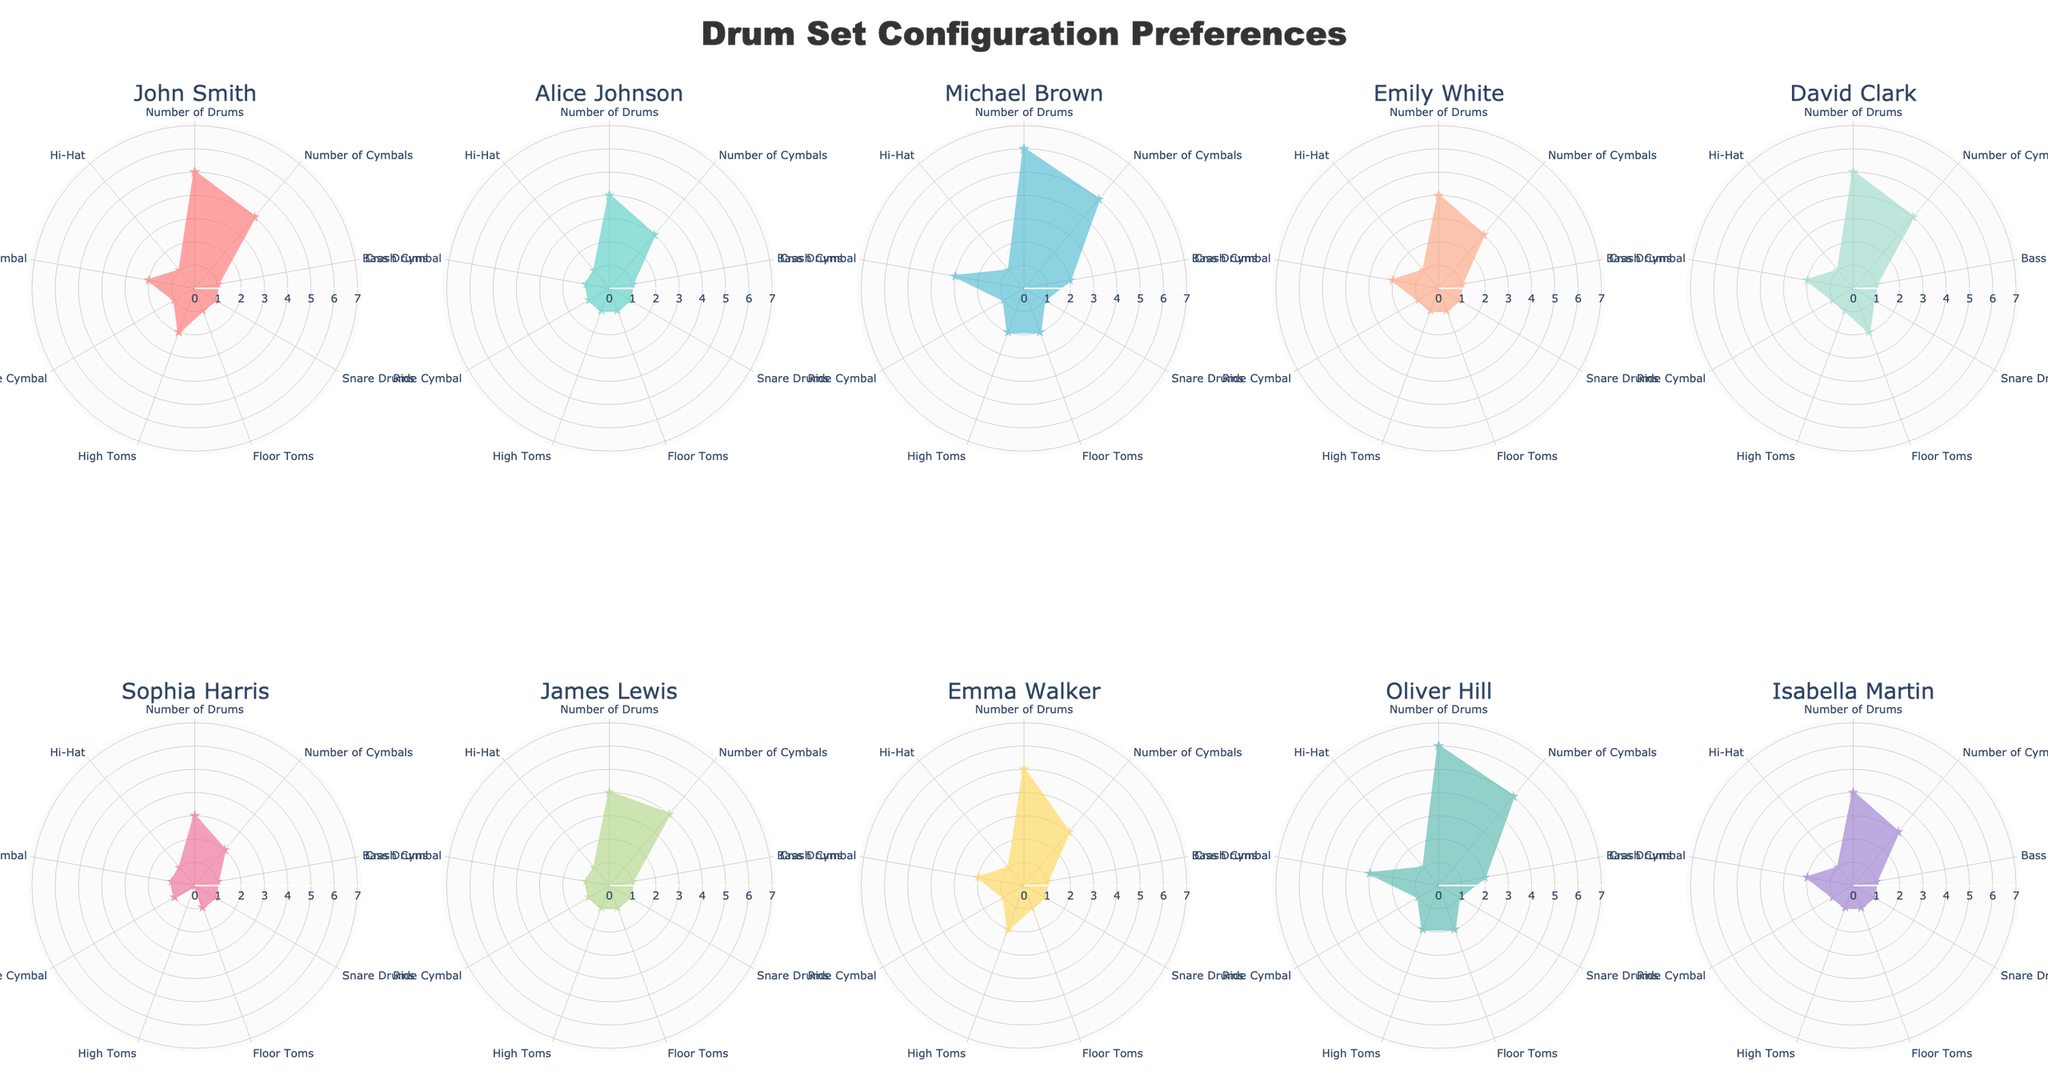Which drummer has the most Bass Drums? Observing the radar charts, Michael Brown and Oliver Hill both have the most Bass Drums, with a count of 2.
Answer: Michael Brown and Oliver Hill Which drummer uses the fewest Cymbals? By looking at each radar chart, Sophia Harris has the fewest Cymbals, using only 2.
Answer: Sophia Harris What is the total number of Bass Drums used by all drummers? Summing the number of Bass Drums from each drummer (1 + 1 + 2 + 1 + 1 + 1 + 1 + 1 + 2 + 1) results in a total of 12 Bass Drums.
Answer: 12 Compare the number of Floor Toms between David Clark and Alice Johnson. Who uses more? Observing their radar charts, David Clark uses 2 Floor Toms while Alice Johnson uses 1. David Clark uses more Floor Toms.
Answer: David Clark Which drummer has the largest drum set (in terms of the number of Drums)? By observing the radar charts, Michael Brown and Oliver Hill have the largest sets with 6 Drums each.
Answer: Michael Brown and Oliver Hill What is the average number of Cymbals used by all drummers? Summing the number of Cymbals from all drummers (4 + 3 + 5 + 3 + 4 + 2 + 4 + 3 + 5 + 3) results in 36, and there are 10 drummers, so the average is 36 / 10 = 3.6.
Answer: 3.6 Compare John Smith’s and Emma Walker’s configurations. Do they use the same number of High Toms? John Smith has 2 High Toms and Emma Walker also has 2 High Toms according to their radar charts.
Answer: Yes Identify the drummer with the simplest (fewest components) configuration. Sophia Harris has the fewest components, with smaller counts across various types of drums and cymbals.
Answer: Sophia Harris How many drummers use more than 1 Ride Cymbal? Observing the radar charts, none of the drummers use more than 1 Ride Cymbal.
Answer: 0 Which drum component does Michael Brown lead in compared to other drummers? By visual inspection, Michael Brown leads in the number of Bass Drums (2) and Crash Cymbals (3) when compared to others.
Answer: Bass Drums and Crash Cymbals 